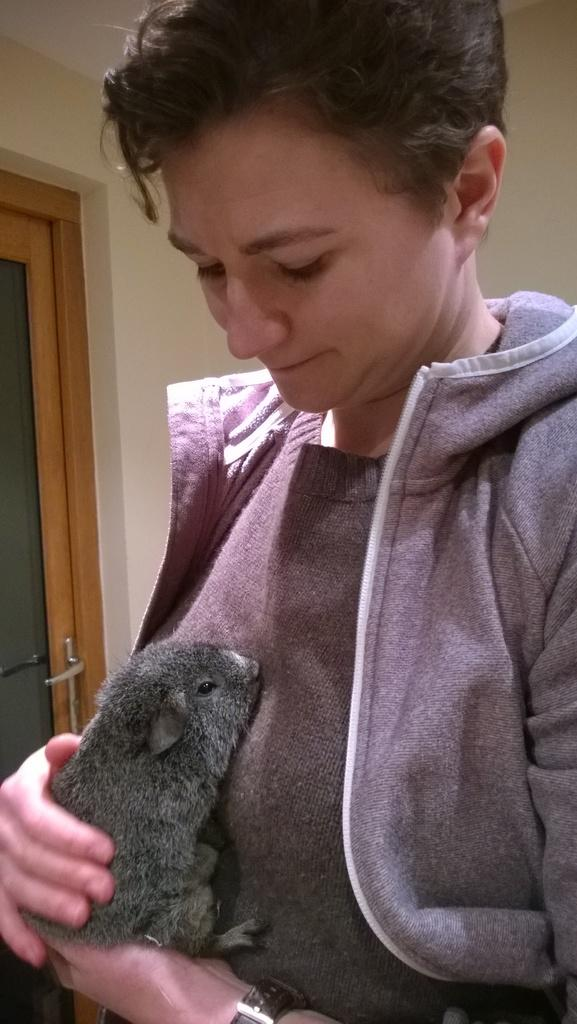What is the main subject of the image? There is a person in the image. What is the person doing in the image? The person is holding an animal. What can be seen in the background of the image? There is a wall and a door in the background of the image. What type of station is visible in the image? There is no station present in the image. What kind of attraction can be seen in the background of the image? There is no attraction visible in the image; only a wall and a door are present in the background. 